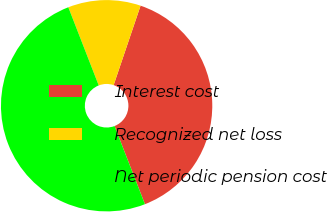<chart> <loc_0><loc_0><loc_500><loc_500><pie_chart><fcel>Interest cost<fcel>Recognized net loss<fcel>Net periodic pension cost<nl><fcel>38.89%<fcel>11.11%<fcel>50.0%<nl></chart> 